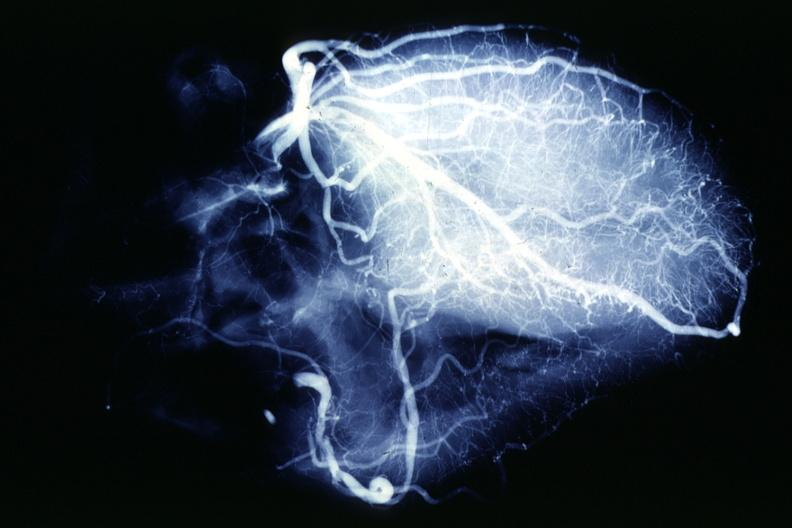does this image show x-ray postmortcoronary angiogram rather typical example of proximal lesions?
Answer the question using a single word or phrase. Yes 